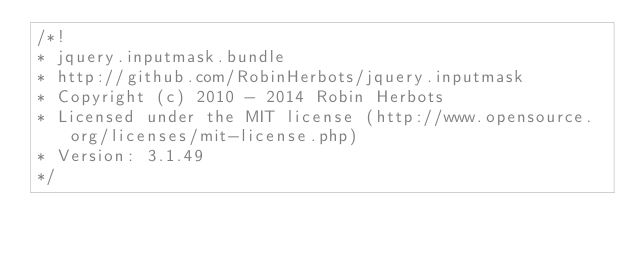<code> <loc_0><loc_0><loc_500><loc_500><_JavaScript_>/*!
* jquery.inputmask.bundle
* http://github.com/RobinHerbots/jquery.inputmask
* Copyright (c) 2010 - 2014 Robin Herbots
* Licensed under the MIT license (http://www.opensource.org/licenses/mit-license.php)
* Version: 3.1.49
*/</code> 